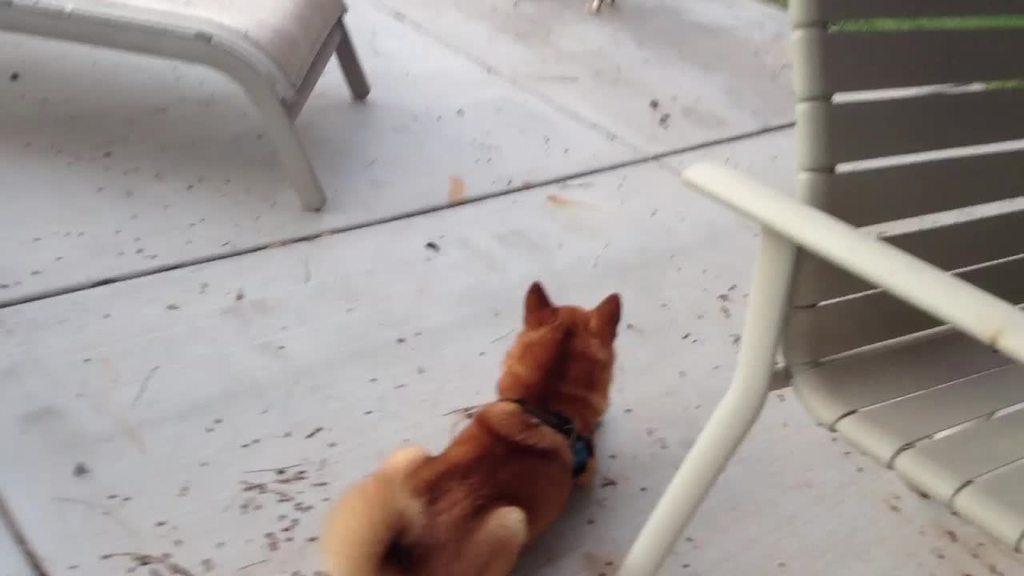Could you give a brief overview of what you see in this image? In this image, we can see a brown color animal on the floor and we can see chairs. 